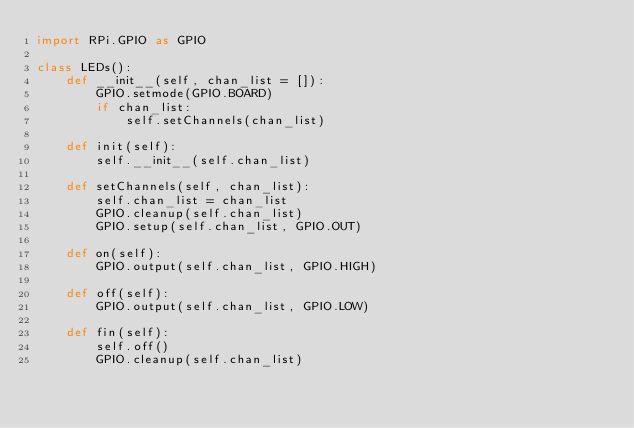Convert code to text. <code><loc_0><loc_0><loc_500><loc_500><_Python_>import RPi.GPIO as GPIO

class LEDs():
    def __init__(self, chan_list = []):
        GPIO.setmode(GPIO.BOARD)
        if chan_list:
            self.setChannels(chan_list)

    def init(self):
        self.__init__(self.chan_list)

    def setChannels(self, chan_list):
        self.chan_list = chan_list
        GPIO.cleanup(self.chan_list)
        GPIO.setup(self.chan_list, GPIO.OUT)

    def on(self):
        GPIO.output(self.chan_list, GPIO.HIGH)

    def off(self):
        GPIO.output(self.chan_list, GPIO.LOW)

    def fin(self):
        self.off()
        GPIO.cleanup(self.chan_list)

</code> 